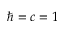Convert formula to latex. <formula><loc_0><loc_0><loc_500><loc_500>\hbar { = } c = 1</formula> 